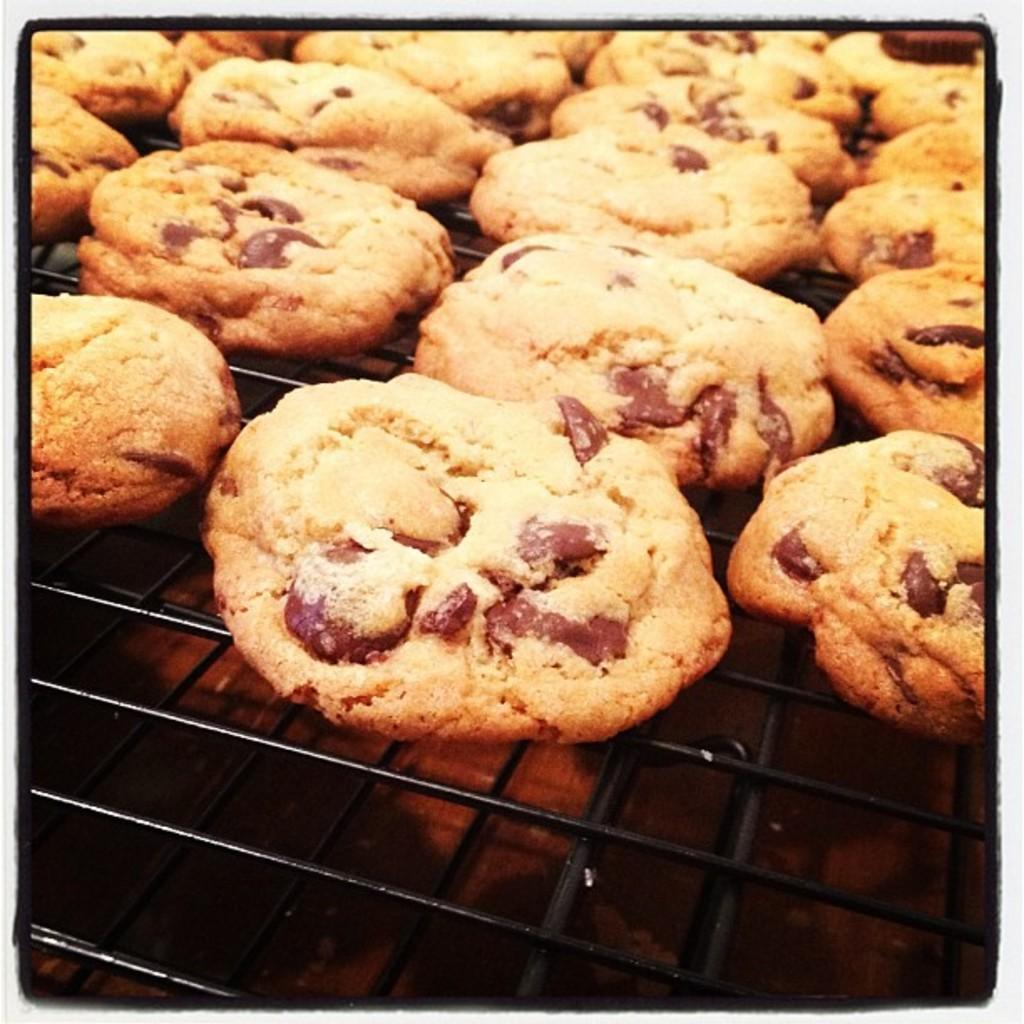What type of food can be seen in the image? There are cookies in the image. Where are the cookies located? The cookies are on a grill. What color is the vein visible in the image? There is no vein present in the image. What type of paint is being used to decorate the cookies in the image? There is no paint or decoration visible on the cookies in the image. 